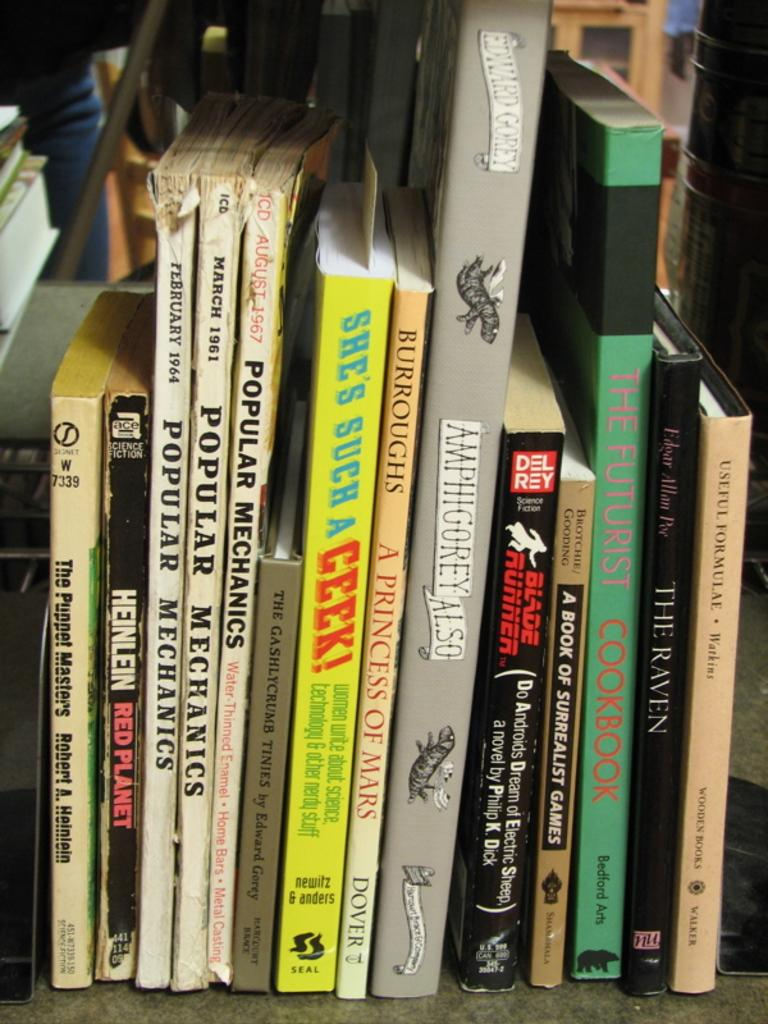<image>
Provide a brief description of the given image. A shelf of books with titles such as Red Planet and She's Such a Geek! 